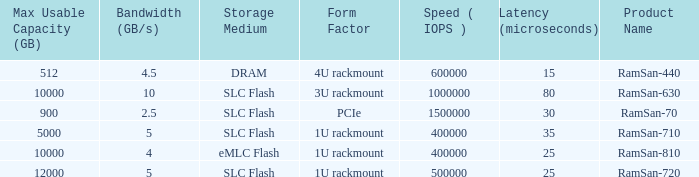List the range distroration for the ramsan-630 3U rackmount. 